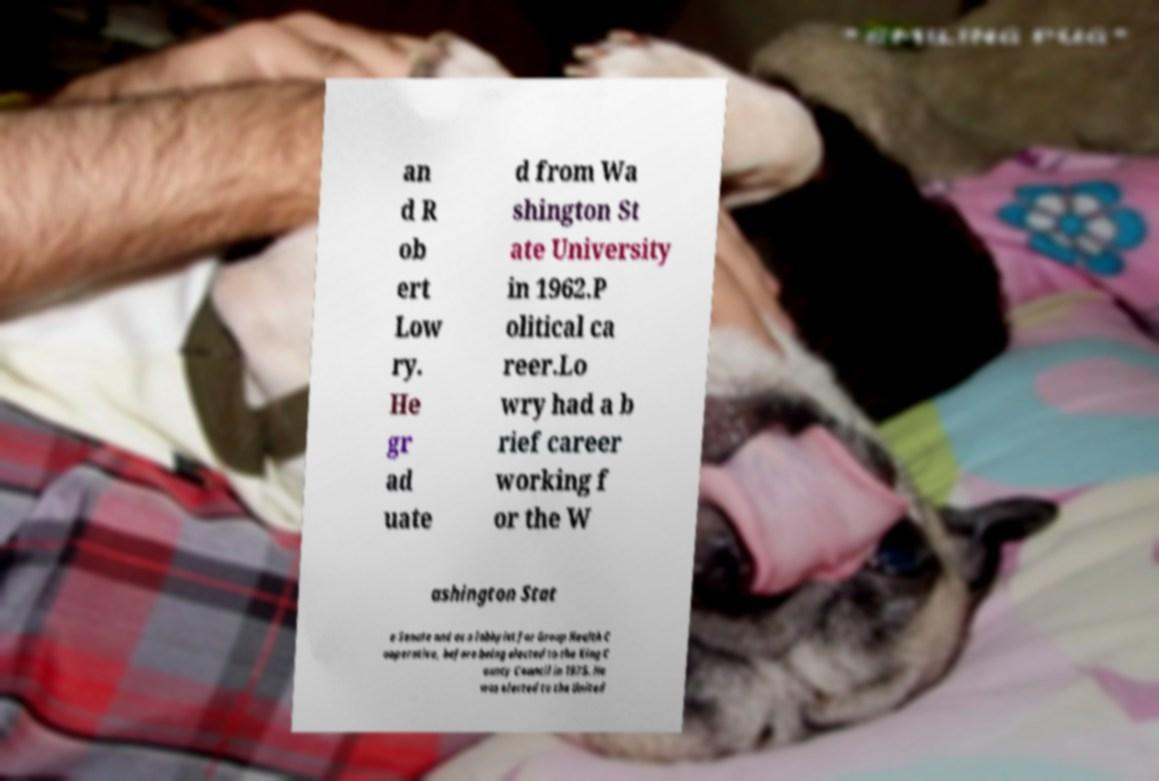For documentation purposes, I need the text within this image transcribed. Could you provide that? an d R ob ert Low ry. He gr ad uate d from Wa shington St ate University in 1962.P olitical ca reer.Lo wry had a b rief career working f or the W ashington Stat e Senate and as a lobbyist for Group Health C ooperative, before being elected to the King C ounty Council in 1975. He was elected to the United 